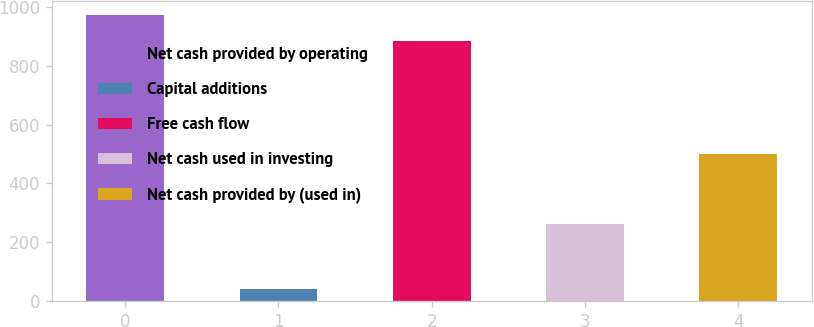Convert chart to OTSL. <chart><loc_0><loc_0><loc_500><loc_500><bar_chart><fcel>Net cash provided by operating<fcel>Capital additions<fcel>Free cash flow<fcel>Net cash used in investing<fcel>Net cash provided by (used in)<nl><fcel>972.95<fcel>42.3<fcel>884.5<fcel>261.9<fcel>498.8<nl></chart> 